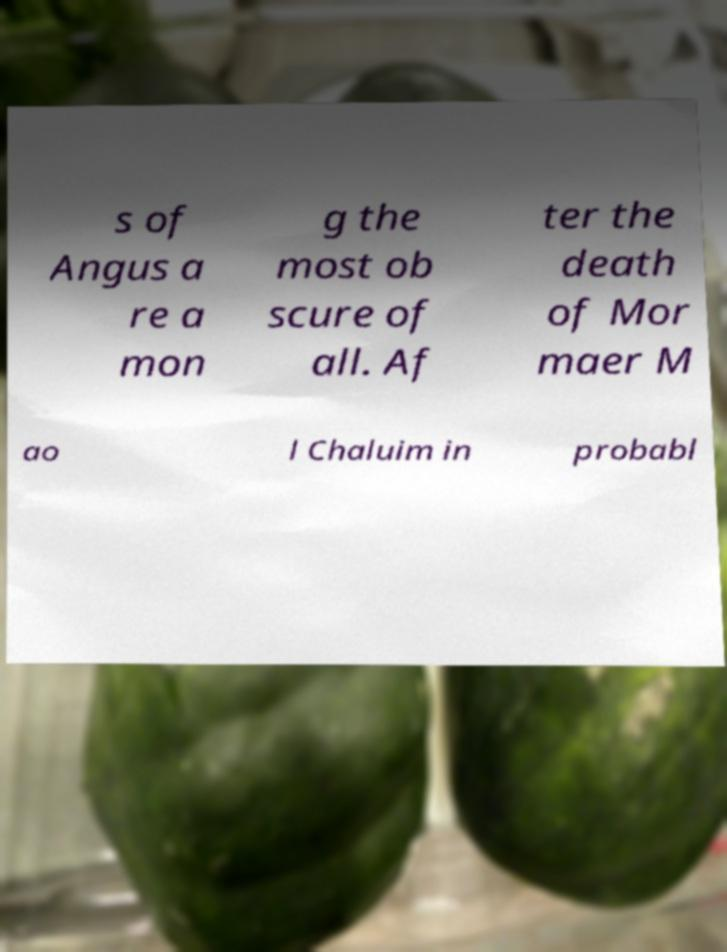For documentation purposes, I need the text within this image transcribed. Could you provide that? s of Angus a re a mon g the most ob scure of all. Af ter the death of Mor maer M ao l Chaluim in probabl 